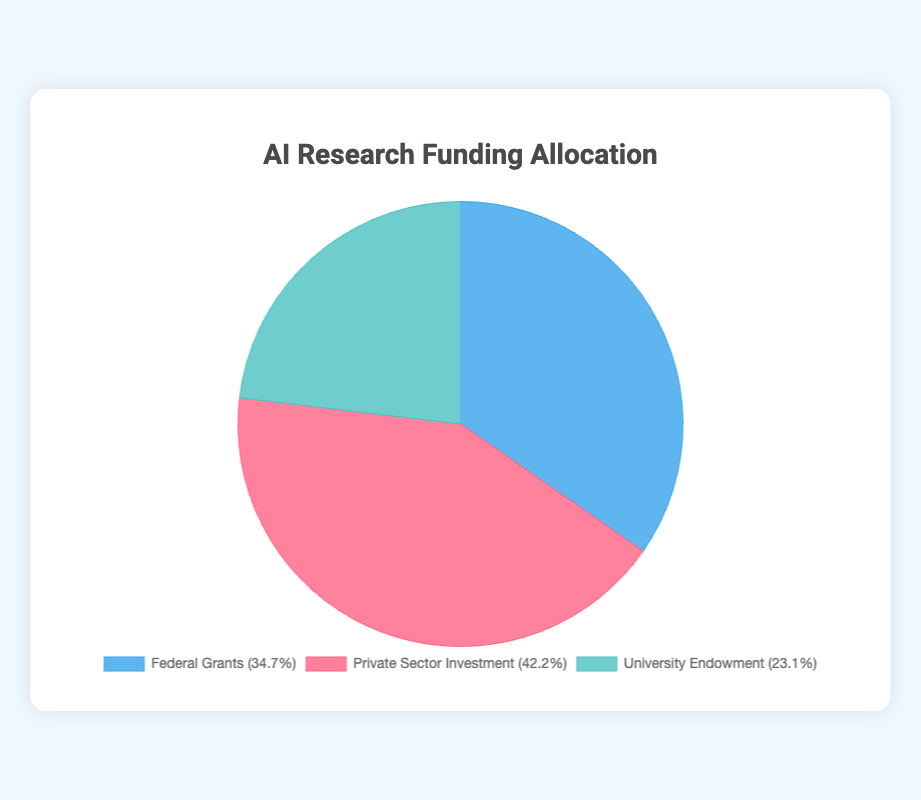What is the largest source of AI research funding? By looking at the sizes of the pie chart slices, we can see which slice is the largest. The Private Sector Investment slice is the largest, indicating it’s the largest source of funding.
Answer: Private Sector Investment How much more does the Private Sector invest compared to University Endowment in AI research? First, identify the amounts for Private Sector Investment ($730M) and University Endowment ($400M) from the pie chart. Then, subtract the University Endowment amount from the Private Sector amount: $730M - $400M = $330M.
Answer: $330M Which source has the smallest contribution to AI research funding? By comparing slice sizes on the pie chart, the smallest slice corresponds to University Endowment, indicating it's the smallest contributor.
Answer: University Endowment What fraction of total AI research funding comes from Federal Grants? Identify the amount for Federal Grants ($600M) and find the total funding by summing the amounts from all sources: $600M (Federal Grants) + $730M (Private Sector) + $400M (University Endowment) = $1730M. Then, divide the Federal Grants amount by the total: $600M / $1730M ≈ 0.346.
Answer: Approximately 0.346 How does the contribution of Google AI compare to the National Science Foundation (NSF)? From the chart, Google AI contributes $300M, and NSF contributes $250M. Google AI contributes more.
Answer: Google AI contributes more What is the percentage contribution of the University Endowment towards AI research funding? First, determine the total funding: $1730M. The University Endowment is $400M. The percentage is calculated as ($400M / $1730M) * 100 ≈ 23.1%.
Answer: Approximately 23.1% Is the combined funding from NIH and IBM Watson greater than from NSF? NIH contributes $150M, and IBM Watson contributes $180M which sum up to $330M ($150M + $180M). NSF alone contributes $250M, so NSF’s contribution is less.
Answer: Yes What proportion of total AI research funding is Federal Grants compared to Private Sector Investment? The proportion is Federal Grants ($600M) divided by Private Sector Investment ($730M): $600M / $730M ≈ 0.82.
Answer: Approximately 0.82 Which has a higher funding amount: MIT University Endowment or DARPA? From the chart data, MIT contributes $150M and DARPA contributes $200M. DARPA has a higher funding amount.
Answer: DARPA What is the combined total funding amount from both Stanford University and Carnegie Mellon University? Adding Stanford ($120M) and Carnegie Mellon University ($130M) gives $120M + $130M = $250M.
Answer: $250M 